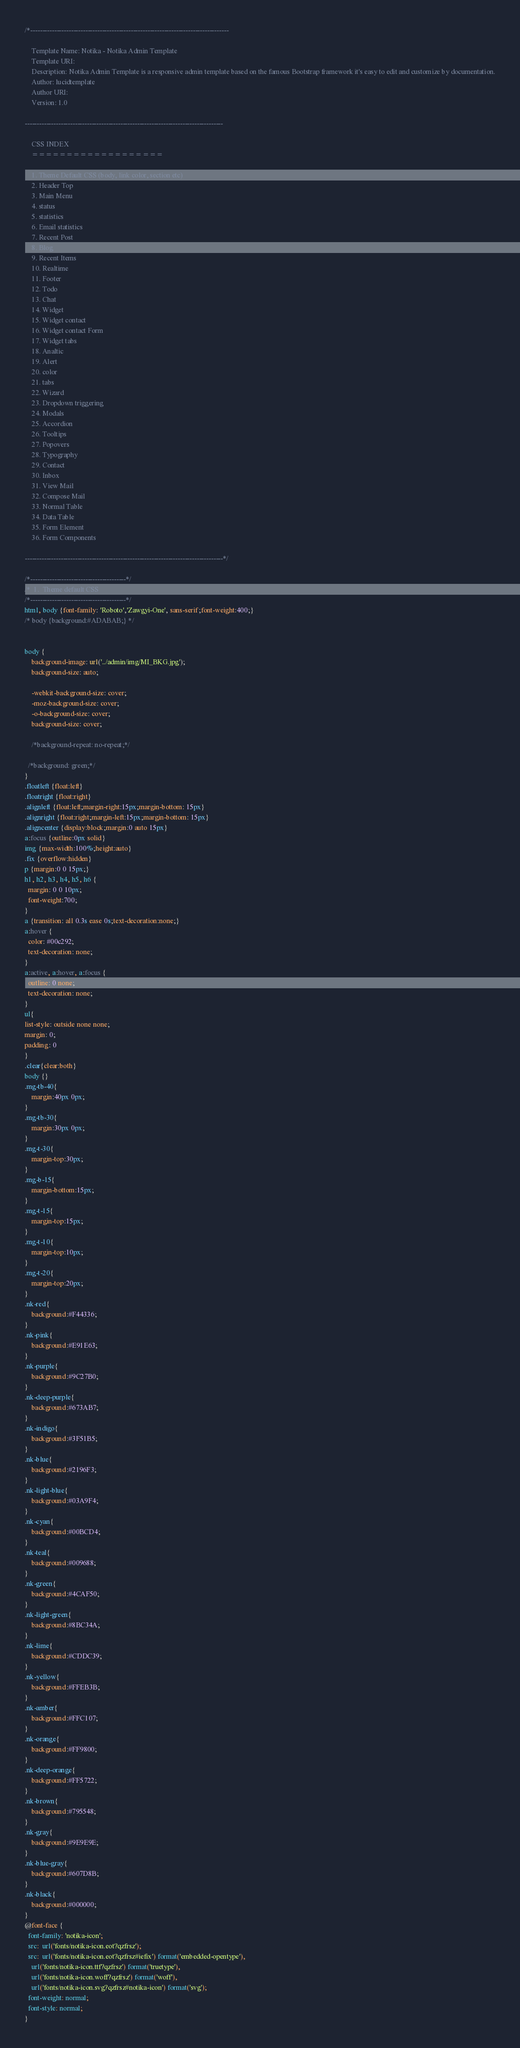Convert code to text. <code><loc_0><loc_0><loc_500><loc_500><_CSS_>/*-----------------------------------------------------------------------------------

    Template Name: Notika - Notika Admin Template
    Template URI:
    Description: Notika Admin Template is a responsive admin template based on the famous Bootstrap framework it's easy to edit and customize by documentation.
    Author: lucidtemplate
    Author URI:
    Version: 1.0

-----------------------------------------------------------------------------------

    CSS INDEX
    ===================

    1. Theme Default CSS (body, link color, section etc)
    2. Header Top
    3. Main Menu
    4. status
    5. statistics
    6. Email statistics
    7. Recent Post
    8. Blog
    9. Recent Items
    10. Realtime
    11. Footer
    12. Todo
    13. Chat
    14. Widget
    15. Widget contact
    16. Widget contact Form
    17. Widget tabs
    18. Analtic
    19. Alert
    20. color
    21. tabs
    22. Wizard
    23. Dropdown triggering
    24. Modals
    25. Accordion
    26. Tooltips
    27. Popovers
    28. Typography
    29. Contact
    30. Inbox
    31. View Mail
    32. Compose Mail
    33. Normal Table
    34. Data Table
    35. Form Element
    36. Form Components

-----------------------------------------------------------------------------------*/

/*----------------------------------------*/
/*  1.  Theme default CSS
/*----------------------------------------*/
html, body {font-family: 'Roboto','Zawgyi-One', sans-serif;font-weight:400;}
/* body {background:#ADABAB;} */


body {
    background-image: url('../admin/img/MI_BKG.jpg');
    background-size: auto;

    -webkit-background-size: cover;
    -moz-background-size: cover;
    -o-background-size: cover;
    background-size: cover;

    /*background-repeat: no-repeat;*/

  /*background: green;*/
}
.floatleft {float:left}
.floatright {float:right}
.alignleft {float:left;margin-right:15px;margin-bottom: 15px}
.alignright {float:right;margin-left:15px;margin-bottom: 15px}
.aligncenter {display:block;margin:0 auto 15px}
a:focus {outline:0px solid}
img {max-width:100%;height:auto}
.fix {overflow:hidden}
p {margin:0 0 15px;}
h1, h2, h3, h4, h5, h6 {
  margin: 0 0 10px;
  font-weight:700;
}
a {transition: all 0.3s ease 0s;text-decoration:none;}
a:hover {
  color: #00c292;
  text-decoration: none;
}
a:active, a:hover, a:focus {
  outline: 0 none;
  text-decoration: none;
}
ul{
list-style: outside none none;
margin: 0;
padding: 0
}
.clear{clear:both}
body {}
.mg-tb-40{
	margin:40px 0px;
}
.mg-tb-30{
	margin:30px 0px;
}
.mg-t-30{
	margin-top:30px;
}
.mg-b-15{
	margin-bottom:15px;
}
.mg-t-15{
	margin-top:15px;
}
.mg-t-10{
	margin-top:10px;
}
.mg-t-20{
	margin-top:20px;
}
.nk-red{
	background:#F44336;
}
.nk-pink{
	background:#E91E63;
}
.nk-purple{
	background:#9C27B0;
}
.nk-deep-purple{
	background:#673AB7;
}
.nk-indigo{
	background:#3F51B5;
}
.nk-blue{
	background:#2196F3;
}
.nk-light-blue{
	background:#03A9F4;
}
.nk-cyan{
	background:#00BCD4;
}
.nk-teal{
	background:#009688;
}
.nk-green{
	background:#4CAF50;
}
.nk-light-green{
	background:#8BC34A;
}
.nk-lime{
	background:#CDDC39;
}
.nk-yellow{
	background:#FFEB3B;
}
.nk-amber{
	background:#FFC107;
}
.nk-orange{
	background:#FF9800;
}
.nk-deep-orange{
	background:#FF5722;
}
.nk-brown{
	background:#795548;
}
.nk-gray{
	background:#9E9E9E;
}
.nk-blue-gray{
	background:#607D8B;
}
.nk-black{
	background:#000000;
}
@font-face {
  font-family: 'notika-icon';
  src:  url('fonts/notika-icon.eot?qzfrsz');
  src:  url('fonts/notika-icon.eot?qzfrsz#iefix') format('embedded-opentype'),
    url('fonts/notika-icon.ttf?qzfrsz') format('truetype'),
    url('fonts/notika-icon.woff?qzfrsz') format('woff'),
    url('fonts/notika-icon.svg?qzfrsz#notika-icon') format('svg');
  font-weight: normal;
  font-style: normal;
}</code> 